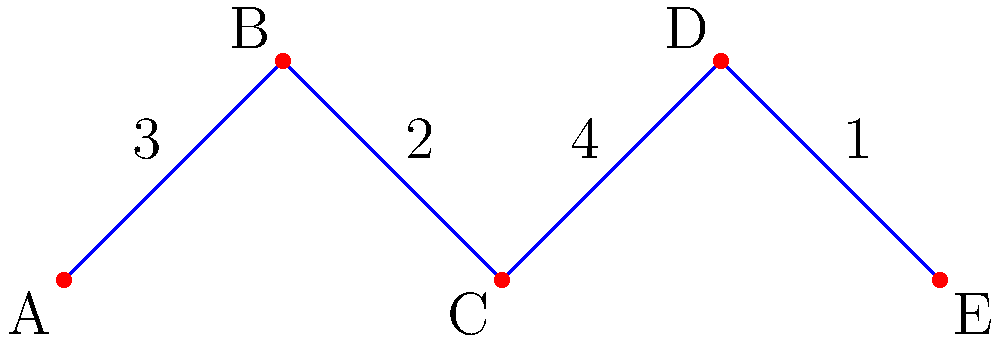Given the network diagram representing your farmland, where vertices are potential barrier locations and edge weights indicate the cost of building barriers between locations (in thousands of dollars), what is the minimum cost to protect your crops by connecting all locations with flood barriers? To find the minimum cost of connecting all locations with flood barriers, we need to find the Minimum Spanning Tree (MST) of the given graph. We can use Kruskal's algorithm to solve this problem:

1. Sort all edges by weight in ascending order:
   DE (1), BC (2), AB (3), CD (4)

2. Start with an empty set of edges and add edges in order, skipping those that would create a cycle:
   - Add DE (1)
   - Add BC (2)
   - Add AB (3)
   - Skip CD (4) as it would create a cycle

3. The MST consists of edges: DE, BC, and AB

4. Calculate the total cost:
   $1 + 2 + 3 = 6$ thousand dollars

Therefore, the minimum cost to protect all crops by connecting all locations with flood barriers is $6,000.
Answer: $6,000 